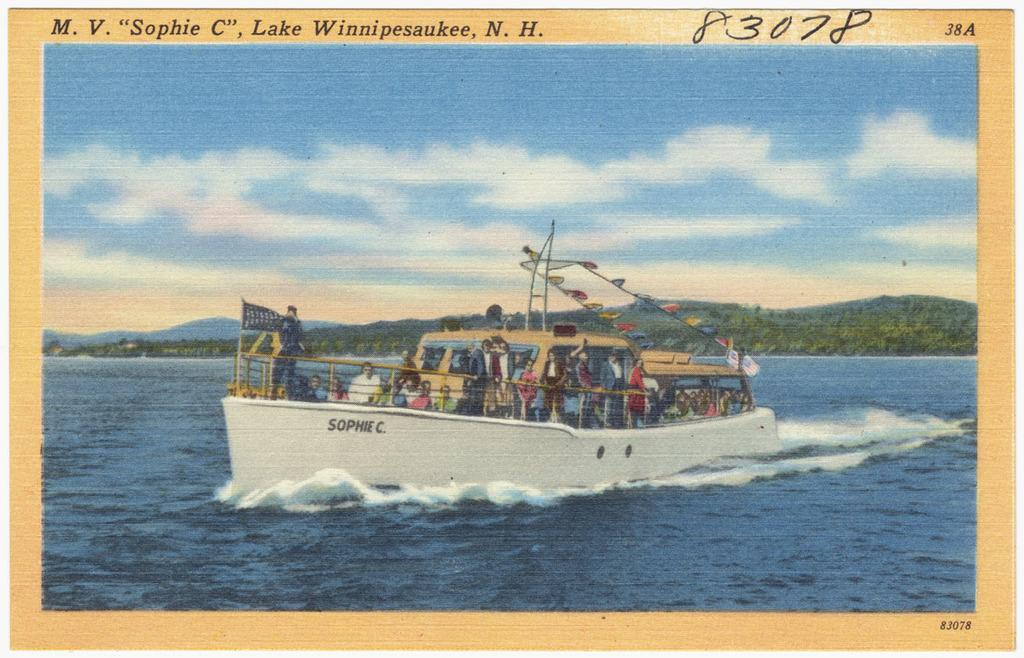<image>
Summarize the visual content of the image. A boat called "Sophie C." transports many people across the water. 